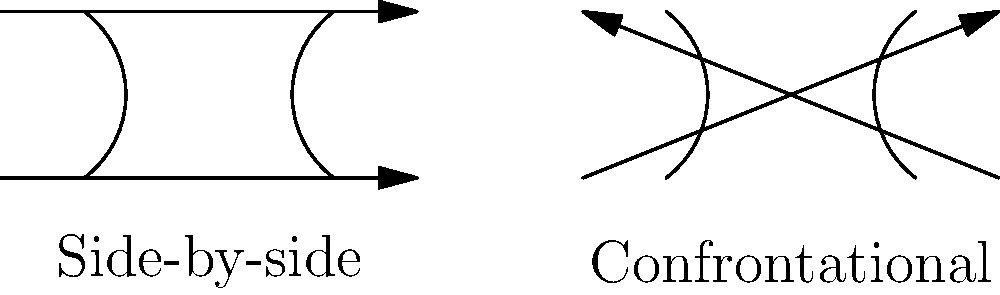In the context of promoting bipartisanship and cooperation, how does the biomechanics of walking side-by-side differ from walking confrontationally, and what implications might this have for political discourse? 1. Walking side-by-side:
   - Bodies are parallel and facing the same direction
   - Center of mass for both individuals moves in the same direction
   - Stride length and pace are likely to synchronize naturally
   - Energy expenditure is distributed evenly between both parties

2. Walking confrontationally:
   - Bodies are facing each other
   - Center of mass for each individual moves in opposite directions
   - Stride length and pace may be irregular or aggressive
   - Energy expenditure may be higher due to tension and potential for sudden movements

3. Biomechanical differences:
   - Side-by-side walking promotes synchronized movement and shared goals
   - Confrontational walking creates opposition and potential for conflict

4. Implications for political discourse:
   - Side-by-side biomechanics can be metaphorically linked to cooperation and shared progress
   - Confrontational biomechanics can be associated with adversarial politics and gridlock

5. Application to bipartisanship:
   - Encouraging "side-by-side" approaches in politics could foster better cooperation
   - Reducing "confrontational" stances may lead to more productive dialogues and compromises

6. Journalistic perspective:
   - Reporting on political interactions could benefit from understanding these biomechanical metaphors
   - Framing political cooperation in terms of "walking side-by-side" could promote bipartisanship
Answer: Side-by-side walking promotes cooperation through synchronized movement and shared direction, while confrontational walking creates opposition, metaphorically representing collaborative vs. adversarial approaches in politics. 